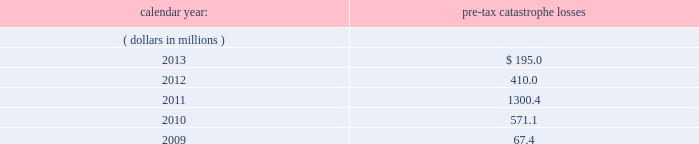Corporate income taxes other than withholding taxes on certain investment income and premium excise taxes .
If group or its bermuda subsidiaries were to become subject to u.s .
Income tax , there could be a material adverse effect on the company 2019s financial condition , results of operations and cash flows .
United kingdom .
Bermuda re 2019s uk branch conducts business in the uk and is subject to taxation in the uk .
Bermuda re believes that it has operated and will continue to operate its bermuda operation in a manner which will not cause them to be subject to uk taxation .
If bermuda re 2019s bermuda operations were to become subject to uk income tax , there could be a material adverse impact on the company 2019s financial condition , results of operations and cash flow .
Ireland .
Holdings ireland and ireland re conduct business in ireland and are subject to taxation in ireland .
Available information .
The company 2019s annual reports on form 10-k , quarterly reports on form 10-q , current reports on form 8- k , proxy statements and amendments to those reports are available free of charge through the company 2019s internet website at http://www.everestregroup.com as soon as reasonably practicable after such reports are electronically filed with the securities and exchange commission ( the 201csec 201d ) .
Item 1a .
Risk factors in addition to the other information provided in this report , the following risk factors should be considered when evaluating an investment in our securities .
If the circumstances contemplated by the individual risk factors materialize , our business , financial condition and results of operations could be materially and adversely affected and the trading price of our common shares could decline significantly .
Risks relating to our business fluctuations in the financial markets could result in investment losses .
Prolonged and severe disruptions in the public debt and equity markets , such as occurred during 2008 , could result in significant realized and unrealized losses in our investment portfolio .
Although financial markets have significantly improved since 2008 , they could deteriorate in the future .
Such declines in the financial markets could result in significant realized and unrealized losses on investments and could have a material adverse impact on our results of operations , equity , business and insurer financial strength and debt ratings .
Our results could be adversely affected by catastrophic events .
We are exposed to unpredictable catastrophic events , including weather-related and other natural catastrophes , as well as acts of terrorism .
Any material reduction in our operating results caused by the occurrence of one or more catastrophes could inhibit our ability to pay dividends or to meet our interest and principal payment obligations .
Subsequent to april 1 , 2010 , we define a catastrophe as an event that causes a loss on property exposures before reinsurance of at least $ 10.0 million , before corporate level reinsurance and taxes .
Prior to april 1 , 2010 , we used a threshold of $ 5.0 million .
By way of illustration , during the past five calendar years , pre-tax catastrophe losses , net of contract specific reinsurance but before cessions under corporate reinsurance programs , were as follows: .

What are the total pre-tax catastrophe losses in the last three years? 
Computations: ((195.0 + 410.0) + 1300.4)
Answer: 1905.4. 